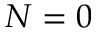Convert formula to latex. <formula><loc_0><loc_0><loc_500><loc_500>N = 0</formula> 